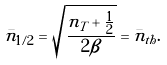Convert formula to latex. <formula><loc_0><loc_0><loc_500><loc_500>\bar { n } _ { 1 / 2 } = \sqrt { \frac { n _ { T } + \frac { 1 } { 2 } } { 2 \beta } } = \bar { n } _ { t h } .</formula> 